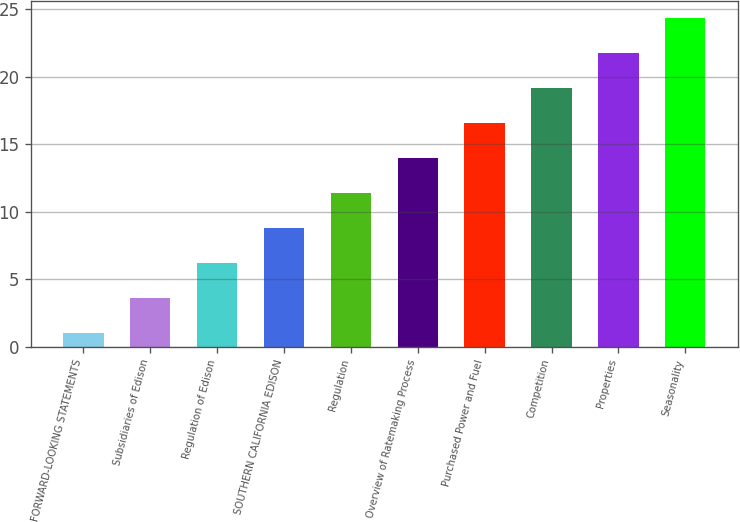Convert chart to OTSL. <chart><loc_0><loc_0><loc_500><loc_500><bar_chart><fcel>FORWARD-LOOKING STATEMENTS<fcel>Subsidiaries of Edison<fcel>Regulation of Edison<fcel>SOUTHERN CALIFORNIA EDISON<fcel>Regulation<fcel>Overview of Ratemaking Process<fcel>Purchased Power and Fuel<fcel>Competition<fcel>Properties<fcel>Seasonality<nl><fcel>1<fcel>3.6<fcel>6.2<fcel>8.8<fcel>11.4<fcel>14<fcel>16.6<fcel>19.2<fcel>21.8<fcel>24.4<nl></chart> 